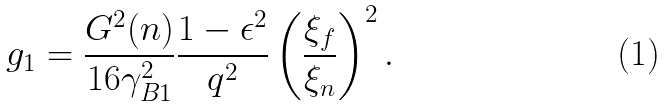Convert formula to latex. <formula><loc_0><loc_0><loc_500><loc_500>g _ { 1 } = \frac { G ^ { 2 } ( n ) } { 1 6 \gamma _ { B 1 } ^ { 2 } } \frac { 1 - \epsilon ^ { 2 } } { q ^ { 2 } } \left ( \frac { \xi _ { f } } { \xi _ { n } } \right ) ^ { 2 } .</formula> 